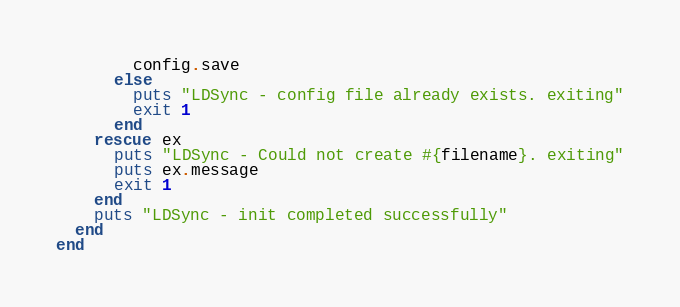<code> <loc_0><loc_0><loc_500><loc_500><_Crystal_>        config.save
      else
        puts "LDSync - config file already exists. exiting"
        exit 1
      end
    rescue ex
      puts "LDSync - Could not create #{filename}. exiting"
      puts ex.message
      exit 1
    end
    puts "LDSync - init completed successfully"
  end
end
</code> 